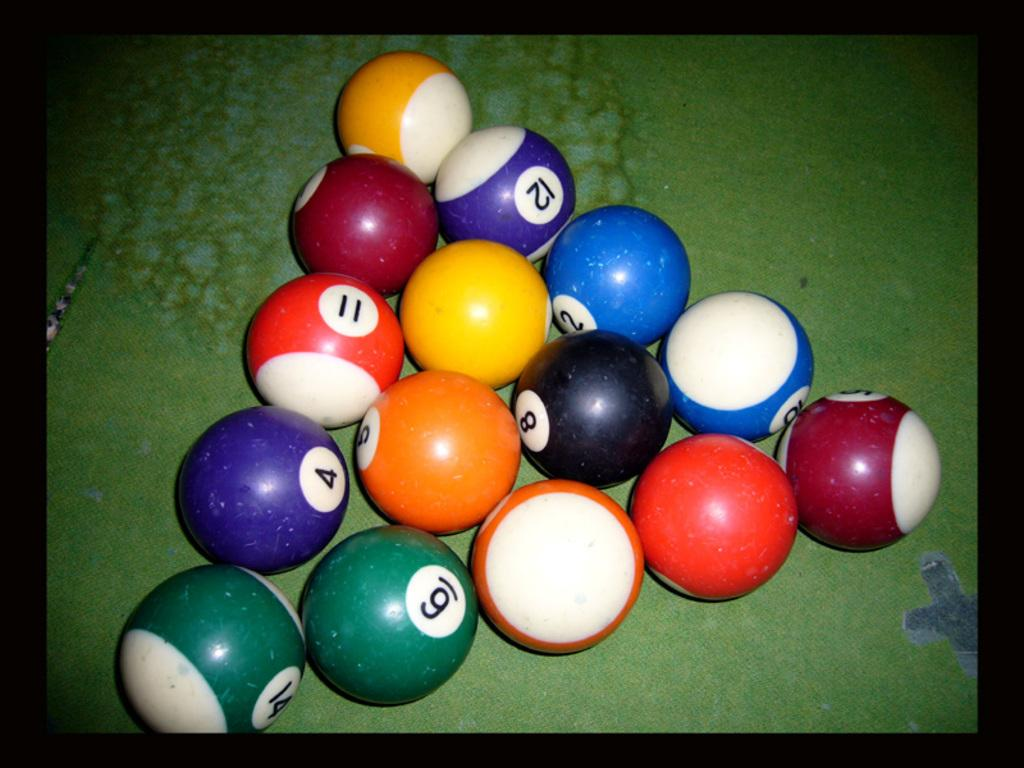What objects are present in the image? There are balls in the image. How are the balls arranged? The balls are arranged in a triangular shape. What type of needle can be seen piercing through the balls in the image? There is no needle present in the image; it only features balls arranged in a triangular shape. 